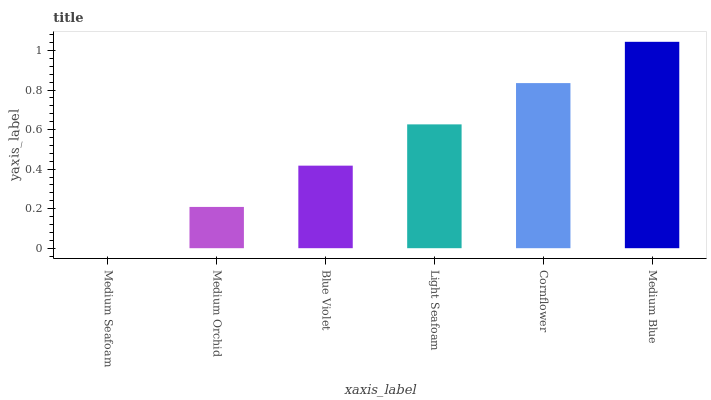Is Medium Seafoam the minimum?
Answer yes or no. Yes. Is Medium Blue the maximum?
Answer yes or no. Yes. Is Medium Orchid the minimum?
Answer yes or no. No. Is Medium Orchid the maximum?
Answer yes or no. No. Is Medium Orchid greater than Medium Seafoam?
Answer yes or no. Yes. Is Medium Seafoam less than Medium Orchid?
Answer yes or no. Yes. Is Medium Seafoam greater than Medium Orchid?
Answer yes or no. No. Is Medium Orchid less than Medium Seafoam?
Answer yes or no. No. Is Light Seafoam the high median?
Answer yes or no. Yes. Is Blue Violet the low median?
Answer yes or no. Yes. Is Medium Orchid the high median?
Answer yes or no. No. Is Medium Blue the low median?
Answer yes or no. No. 